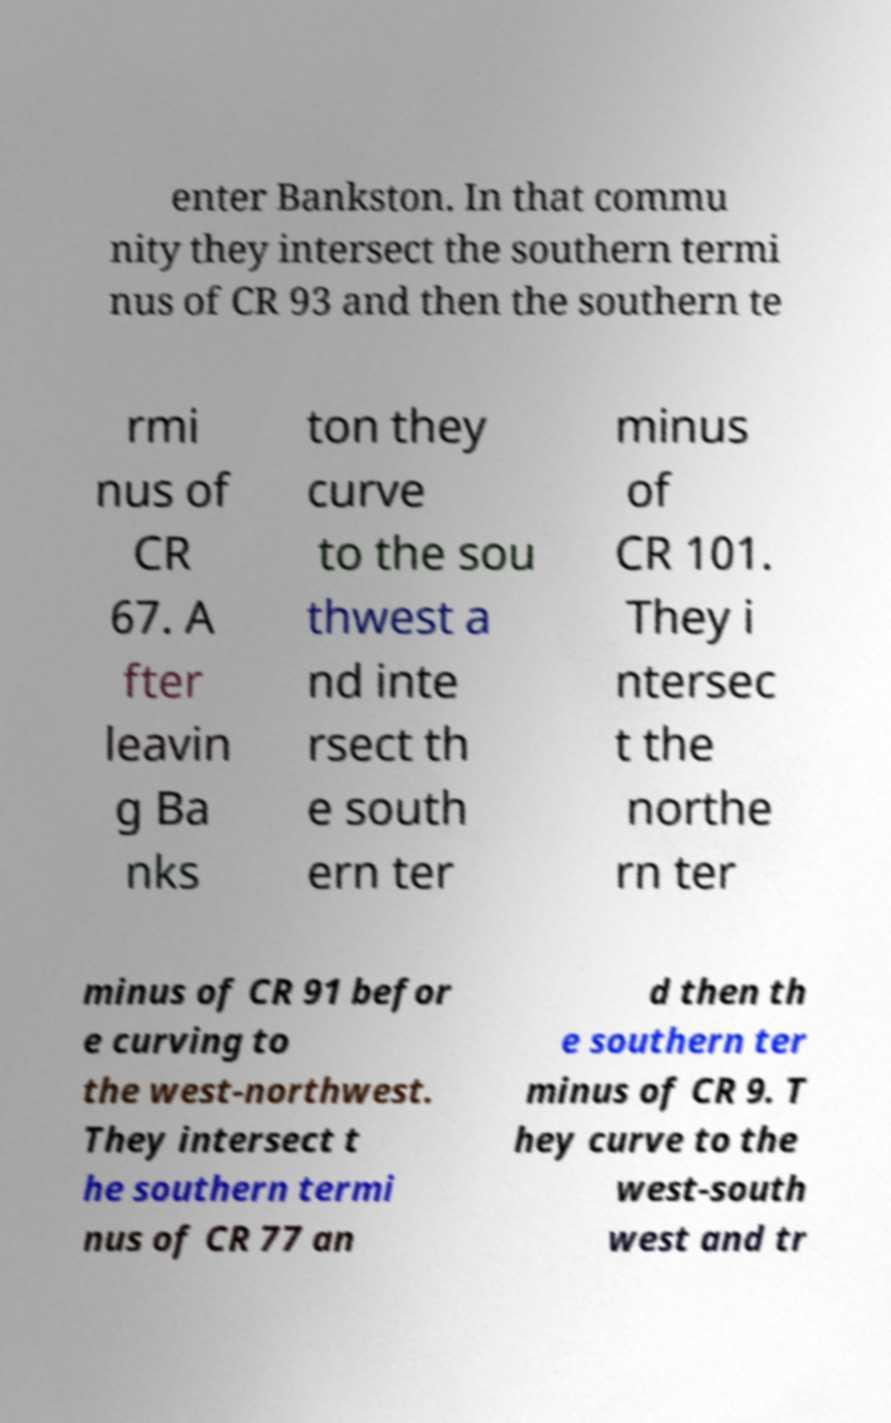Could you assist in decoding the text presented in this image and type it out clearly? enter Bankston. In that commu nity they intersect the southern termi nus of CR 93 and then the southern te rmi nus of CR 67. A fter leavin g Ba nks ton they curve to the sou thwest a nd inte rsect th e south ern ter minus of CR 101. They i ntersec t the northe rn ter minus of CR 91 befor e curving to the west-northwest. They intersect t he southern termi nus of CR 77 an d then th e southern ter minus of CR 9. T hey curve to the west-south west and tr 